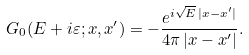<formula> <loc_0><loc_0><loc_500><loc_500>G _ { 0 } ( E + i \varepsilon ; { x } , { x } ^ { \prime } ) = - \frac { e ^ { i \sqrt { E } \, | { x } - { x } ^ { \prime } | } } { 4 \pi \, | { x } - { x } ^ { \prime } | } .</formula> 